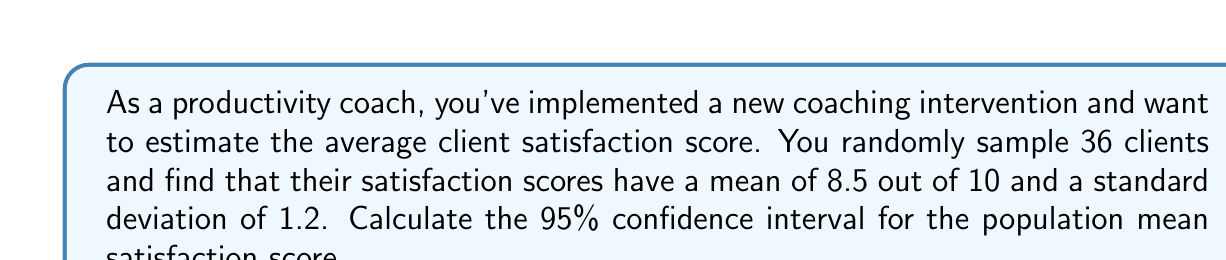Teach me how to tackle this problem. To calculate the confidence interval, we'll follow these steps:

1) First, recall the formula for the confidence interval of a population mean:

   $$\bar{x} \pm t_{\alpha/2} \cdot \frac{s}{\sqrt{n}}$$

   Where:
   $\bar{x}$ is the sample mean
   $t_{\alpha/2}$ is the t-value for the desired confidence level
   $s$ is the sample standard deviation
   $n$ is the sample size

2) We know:
   $\bar{x} = 8.5$
   $s = 1.2$
   $n = 36$
   Confidence level = 95% (so $\alpha = 0.05$)

3) For a 95% confidence interval with 35 degrees of freedom (n-1), the t-value is approximately 2.030 (from t-distribution table).

4) Now, let's substitute these values into our formula:

   $$8.5 \pm 2.030 \cdot \frac{1.2}{\sqrt{36}}$$

5) Simplify:
   $$8.5 \pm 2.030 \cdot \frac{1.2}{6}$$
   $$8.5 \pm 2.030 \cdot 0.2$$
   $$8.5 \pm 0.406$$

6) Therefore, the confidence interval is:
   $$(8.5 - 0.406, 8.5 + 0.406)$$
   $$(8.094, 8.906)$$
Answer: (8.094, 8.906) 